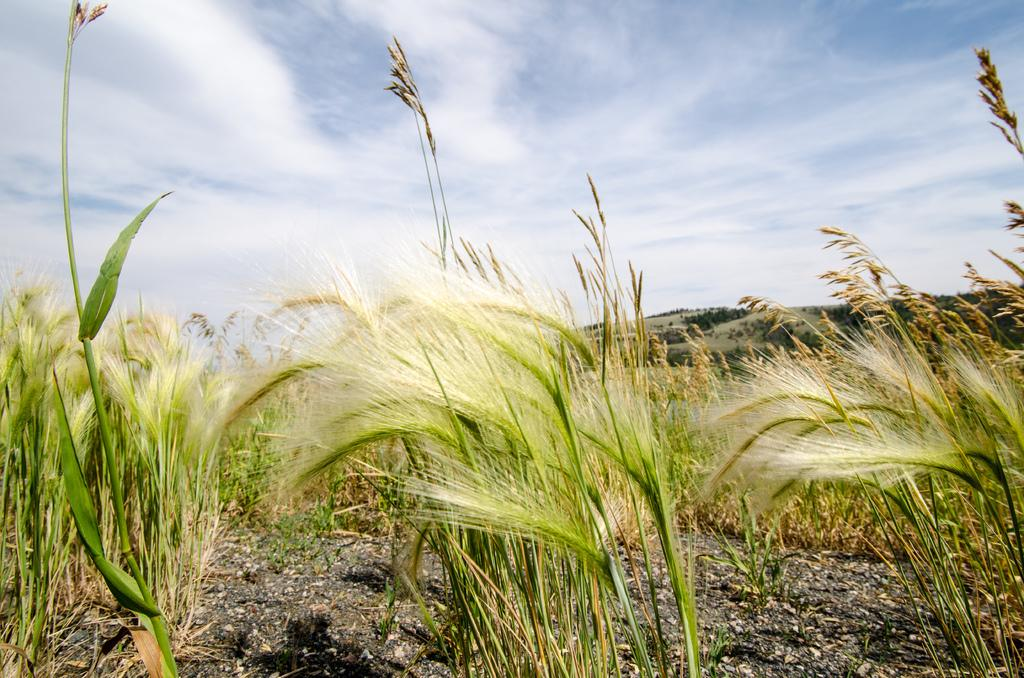What type of plants are in the image? There are wheat plants in the image. What part of the natural environment is visible at the bottom of the image? The ground is visible at the bottom of the image. What part of the natural environment is visible at the top of the image? The sky is visible at the top of the image. What type of fruit is hanging from the wheat plants in the image? There is no fruit hanging from the wheat plants in the image. What is the wheat plant using to poke the ground in the image? Wheat plants do not have the ability to poke the ground, and there are no sticks or fingers present in the image. 